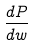<formula> <loc_0><loc_0><loc_500><loc_500>\frac { d P } { d w }</formula> 